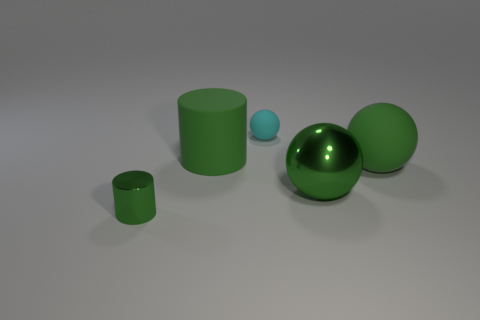Add 5 metal things. How many objects exist? 10 Subtract all cylinders. How many objects are left? 3 Add 2 gray matte cylinders. How many gray matte cylinders exist? 2 Subtract 0 brown balls. How many objects are left? 5 Subtract all small blue metal cylinders. Subtract all green matte things. How many objects are left? 3 Add 5 small matte objects. How many small matte objects are left? 6 